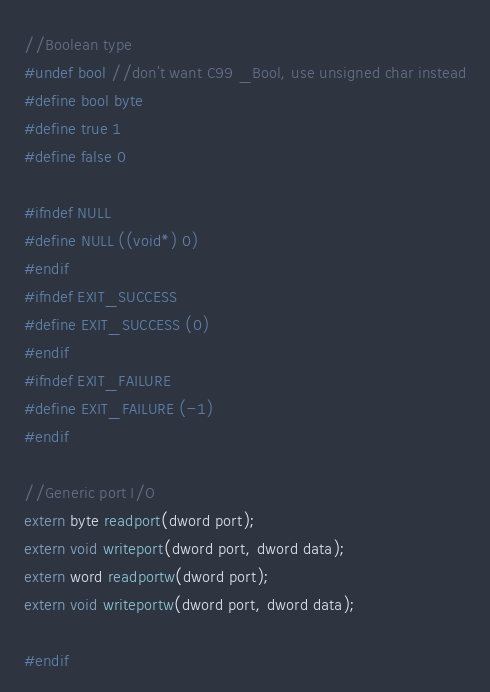<code> <loc_0><loc_0><loc_500><loc_500><_C_>//Boolean type
#undef bool //don't want C99 _Bool, use unsigned char instead
#define bool byte
#define true 1
#define false 0

#ifndef NULL
#define NULL ((void*) 0)
#endif
#ifndef EXIT_SUCCESS
#define EXIT_SUCCESS (0)
#endif
#ifndef EXIT_FAILURE
#define EXIT_FAILURE (-1)
#endif

//Generic port I/O
extern byte readport(dword port);
extern void writeport(dword port, dword data);
extern word readportw(dword port);
extern void writeportw(dword port, dword data);

#endif

</code> 